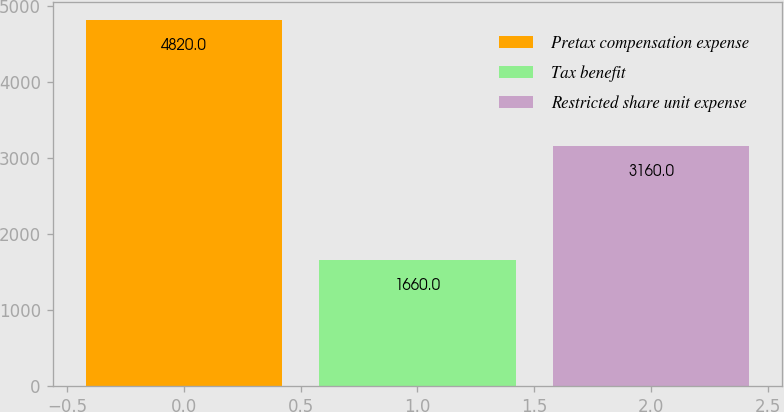Convert chart to OTSL. <chart><loc_0><loc_0><loc_500><loc_500><bar_chart><fcel>Pretax compensation expense<fcel>Tax benefit<fcel>Restricted share unit expense<nl><fcel>4820<fcel>1660<fcel>3160<nl></chart> 